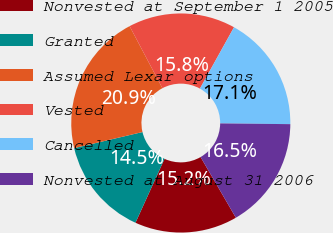<chart> <loc_0><loc_0><loc_500><loc_500><pie_chart><fcel>Nonvested at September 1 2005<fcel>Granted<fcel>Assumed Lexar options<fcel>Vested<fcel>Cancelled<fcel>Nonvested at August 31 2006<nl><fcel>15.17%<fcel>14.53%<fcel>20.94%<fcel>15.81%<fcel>17.09%<fcel>16.45%<nl></chart> 